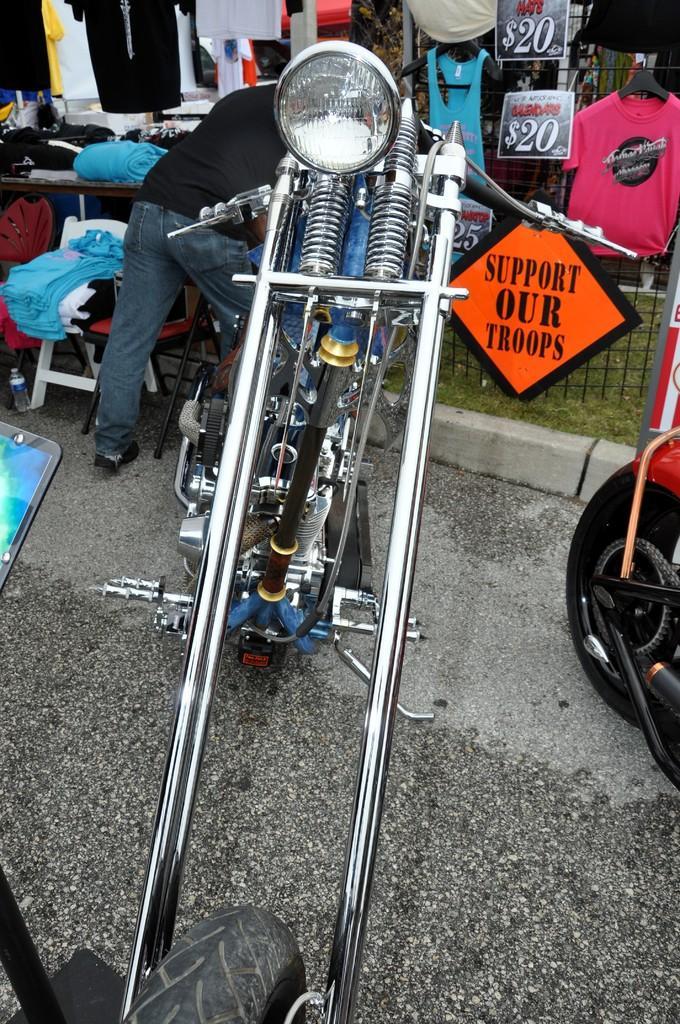Can you describe this image briefly? In this picture we can see a bike in the front, on the left side there is a person standing, on the right side we can see a board, there is some text on the board, in the background there are some t-shirts, price tags and grass, we can also see a table and a mobile phone on the left side. 